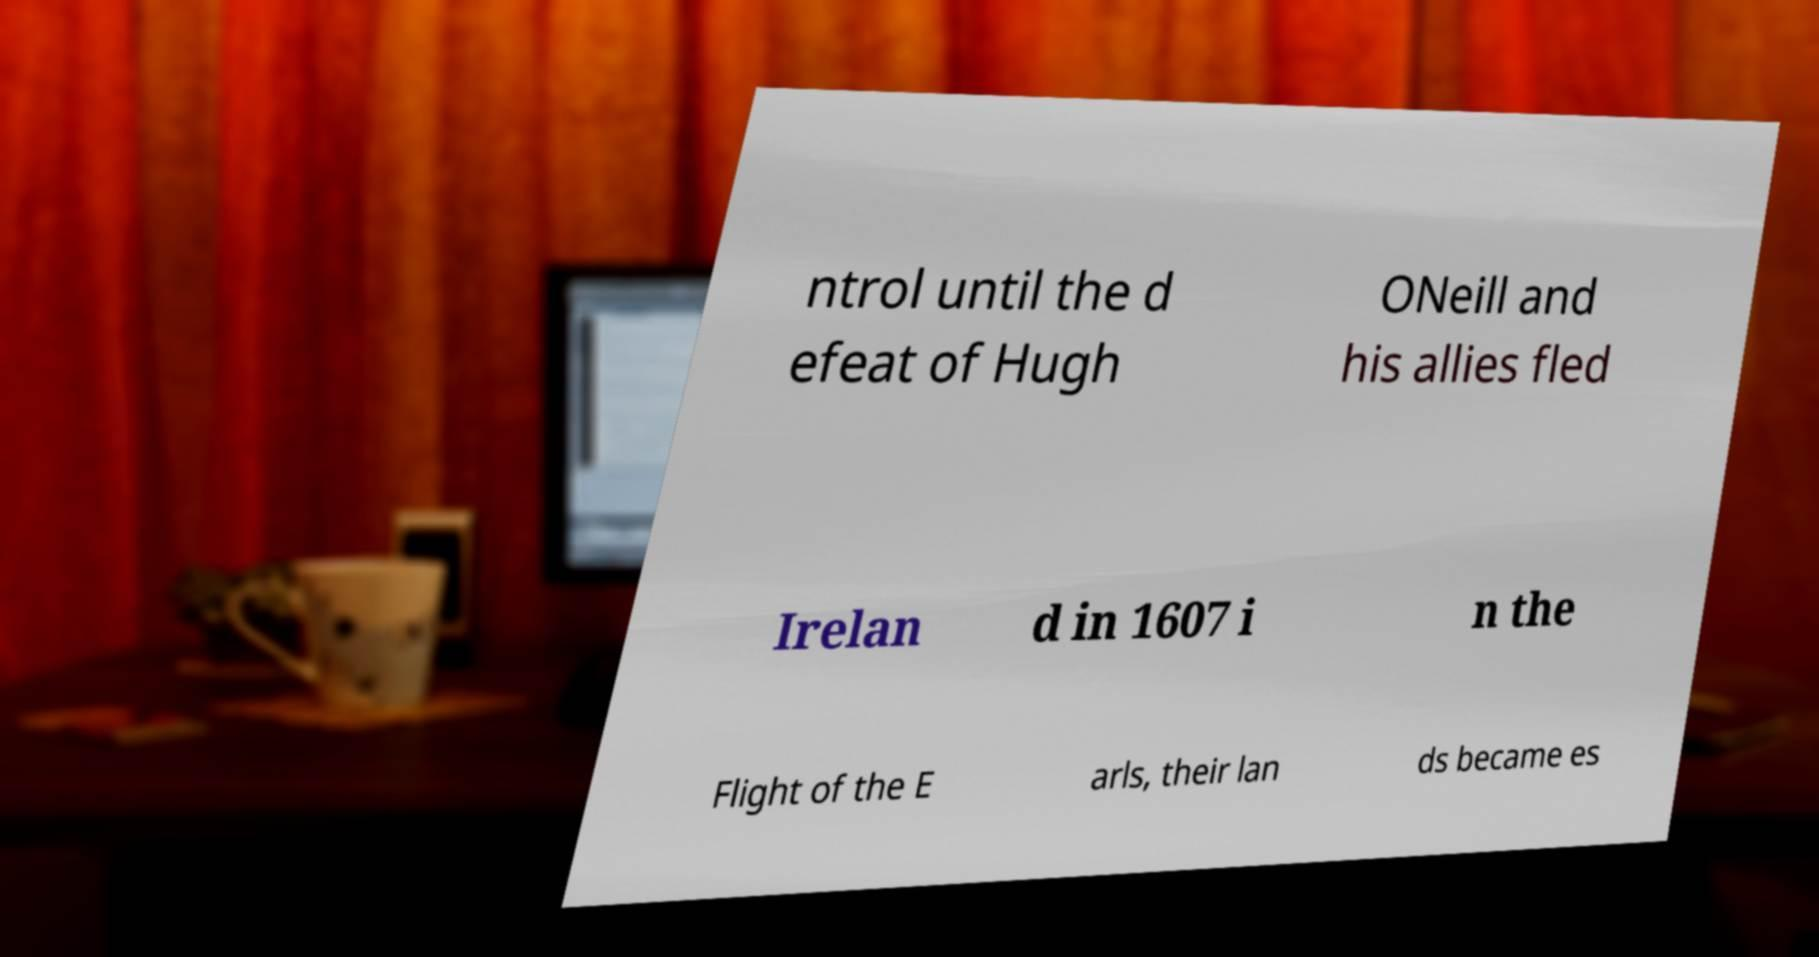Can you read and provide the text displayed in the image?This photo seems to have some interesting text. Can you extract and type it out for me? ntrol until the d efeat of Hugh ONeill and his allies fled Irelan d in 1607 i n the Flight of the E arls, their lan ds became es 